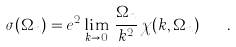<formula> <loc_0><loc_0><loc_500><loc_500>\sigma ( \Omega _ { n } ) = e ^ { 2 } \lim _ { { k } \rightarrow 0 } \, \frac { \Omega _ { n } } { { k } ^ { 2 } } \, \chi ( { k } , \Omega _ { n } ) \quad .</formula> 